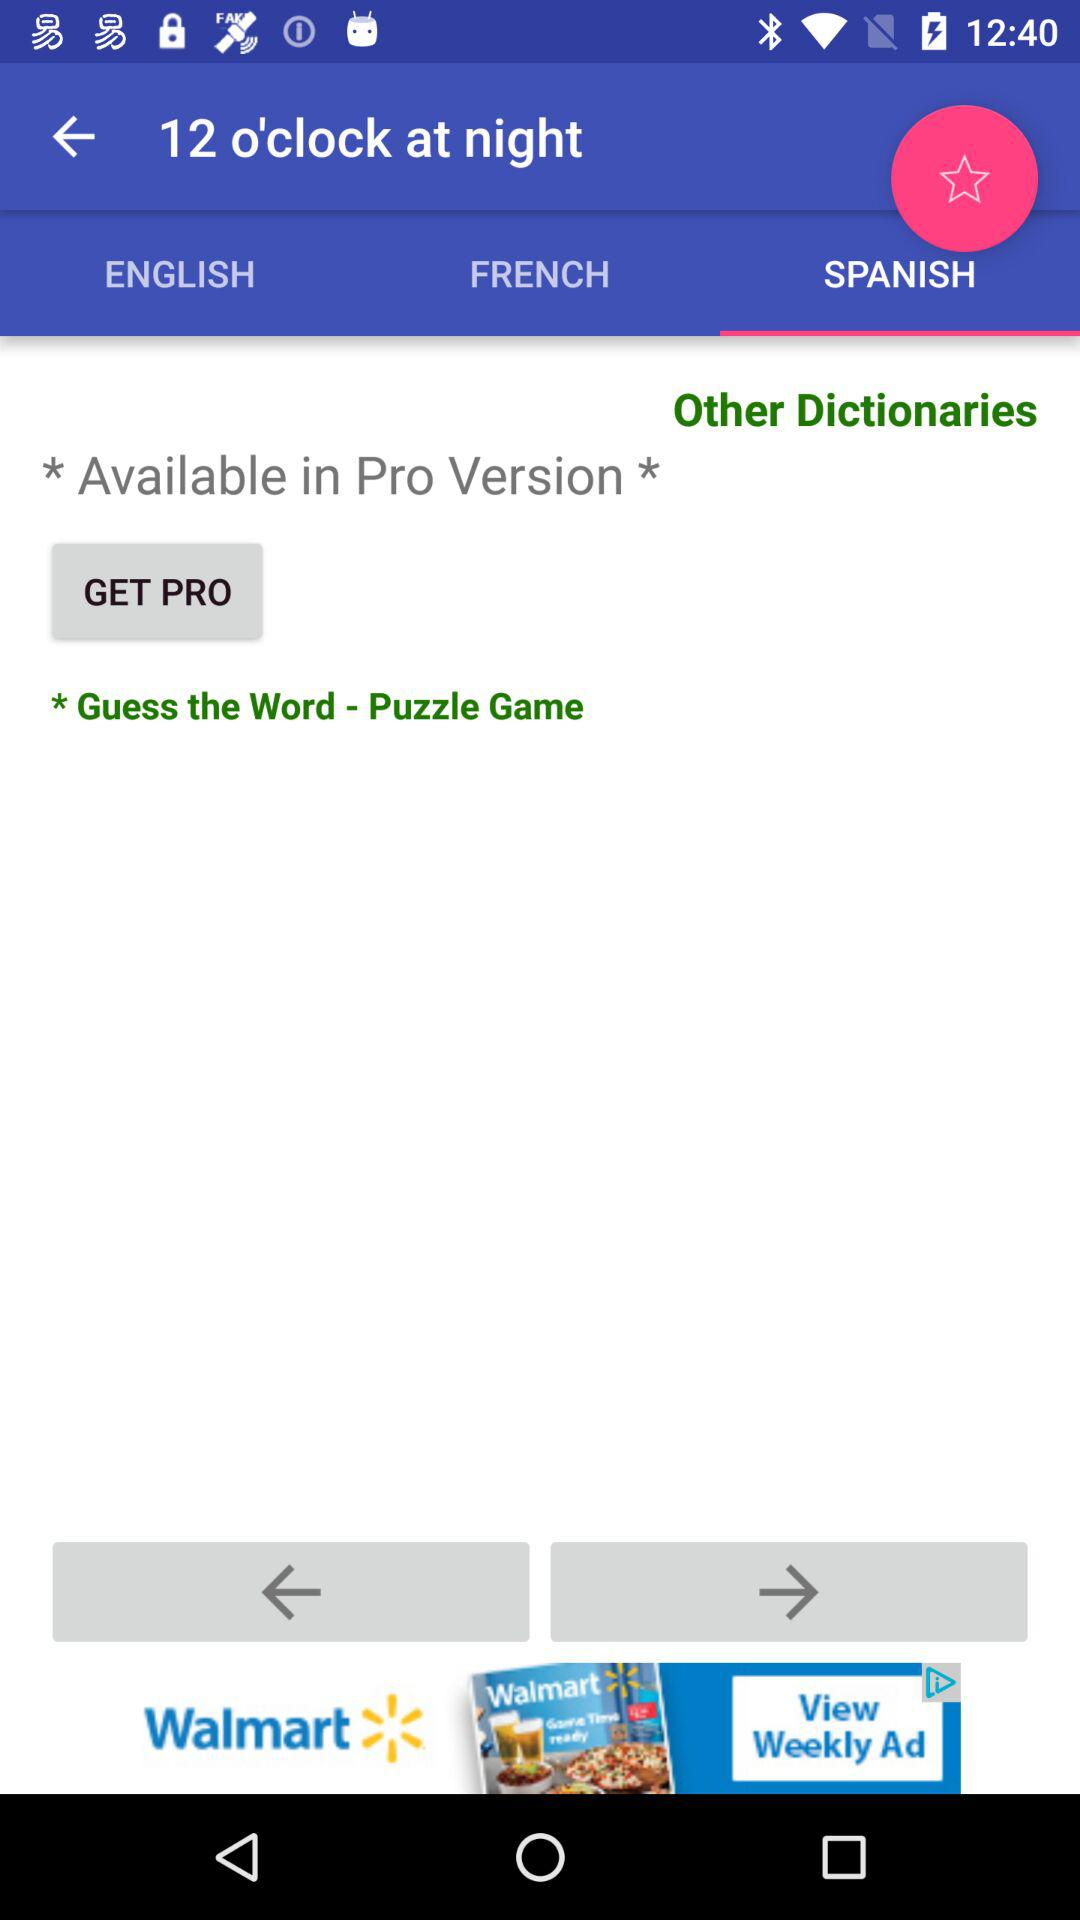Which language is selected? The selected language is Spanish. 